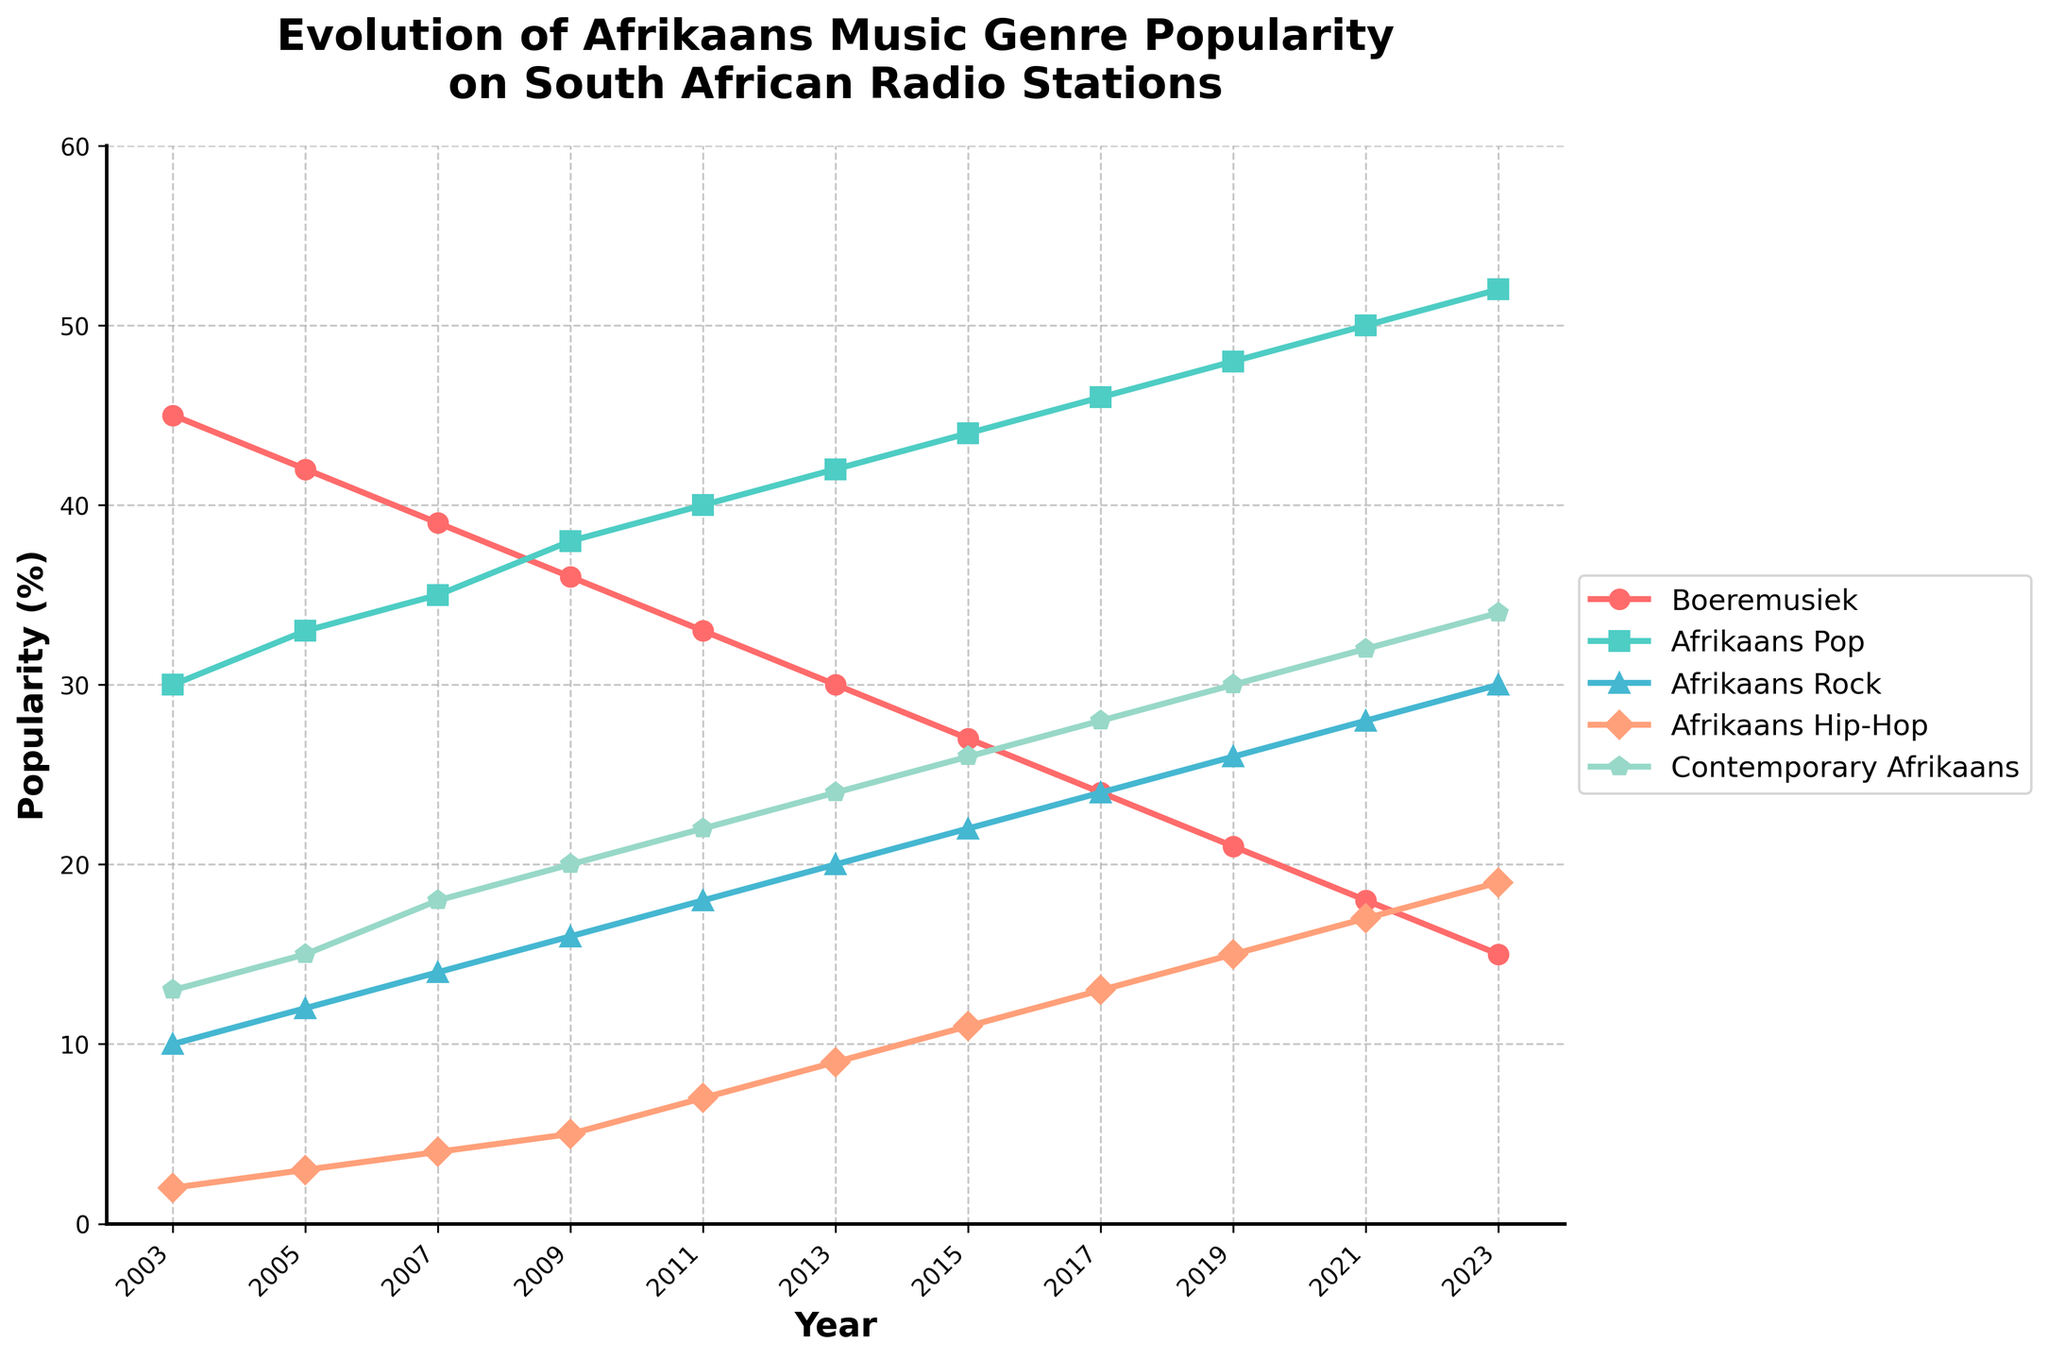What genre was the most popular in 2003? To determine the most popular genre in 2003, we look at the data for that year and see which percentage value is the highest. The highest value in 2003 is for Boeremusiek at 45%.
Answer: Boeremusiek How did the popularity of Afrikaans Rock change from 2003 to 2023? Compare the popularity percentages of Afrikaans Rock in 2003 (10%) and 2023 (30%). Calculate the difference: 30% - 10%. This indicates the increase.
Answer: Increased by 20% In which year did Contemporary Afrikaans reach a popularity of 30%? Look at the data for Contemporary Afrikaans and identify the year when it first reached a 30% popularity level. From the data, this is evident in 2019.
Answer: 2019 What is the least popular genre in 2023? Compare the 2023 data percentages for all genres to determine which one is the lowest. The lowest percentage in 2023 is for Boeremusiek at 15%.
Answer: Boeremusiek Which genre saw the steadiest increase in popularity over the 20-year period? Analyze the trend lines for each genre to see which one shows a consistently upward trajectory without major fluctuations. Contemporary Afrikaans shows a steady increase from 2003 to 2023.
Answer: Contemporary Afrikaans Compare the popularity of Afrikaans Hip-Hop and Afrikaans Pop in 2011. Check the percentages for both genres in the year 2011. Afrikaans Hip-Hop has 7%, and Afrikaans Pop has 40%. Compare these values.
Answer: Afrikaans Pop is more popular In what year did the popularity of Boeremusiek and Afrikaans Rock equal each other? Examine the years where the popularity lines for Boeremusiek and Afrikaans Rock intersect. This occurs in 2015, where both have a 27% popularity.
Answer: 2015 What is the average popularity of Boeremusiek from 2003 to 2023? Sum the popularity percentages of Boeremusiek for all the years and then divide by the number of years (11). Calculation: (45+42+39+36+33+30+27+24+21+18+15)/11 = 30.
Answer: 30 How did the popularity of Afrikaans Hip-Hop evolve between 2005 and 2021? Compare the values of Afrikaans Hip-Hop in 2005 (3%) and 2021 (17%). The popularity increased by 14%. Analyze the trend over the years to see a general rise.
Answer: Increased by 14% Was Afrikaans Pop ever less popular than Afrikaans Rock during the 20 years? Look at the plots for Afrikaans Pop and Afrikaans Rock to check if the percentage for Afrikaans Pop ever drops below that of Afrikaans Rock. It does not; Afrikaans Pop has always been more popular.
Answer: No 